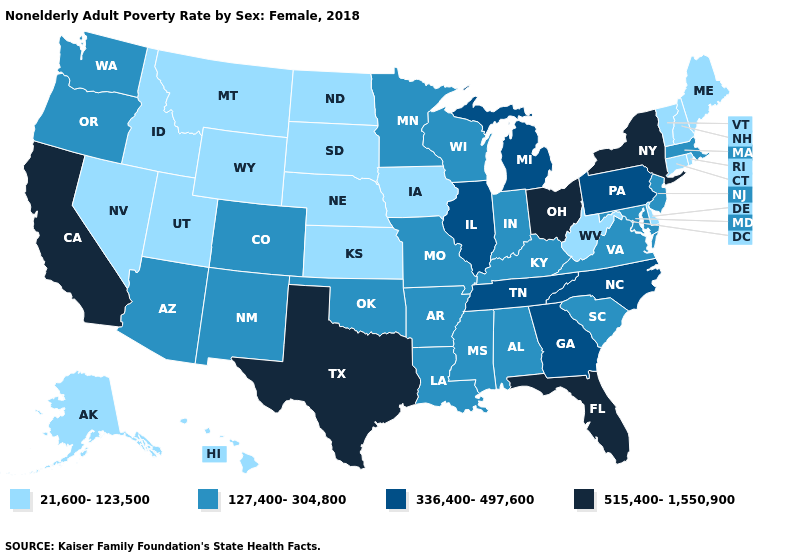What is the value of Mississippi?
Answer briefly. 127,400-304,800. What is the value of Massachusetts?
Concise answer only. 127,400-304,800. What is the value of Maryland?
Concise answer only. 127,400-304,800. How many symbols are there in the legend?
Concise answer only. 4. Does West Virginia have the lowest value in the South?
Be succinct. Yes. Name the states that have a value in the range 515,400-1,550,900?
Write a very short answer. California, Florida, New York, Ohio, Texas. Among the states that border North Carolina , which have the highest value?
Give a very brief answer. Georgia, Tennessee. Which states hav the highest value in the MidWest?
Keep it brief. Ohio. Does Tennessee have the highest value in the South?
Give a very brief answer. No. Name the states that have a value in the range 515,400-1,550,900?
Quick response, please. California, Florida, New York, Ohio, Texas. Is the legend a continuous bar?
Answer briefly. No. Which states have the lowest value in the USA?
Concise answer only. Alaska, Connecticut, Delaware, Hawaii, Idaho, Iowa, Kansas, Maine, Montana, Nebraska, Nevada, New Hampshire, North Dakota, Rhode Island, South Dakota, Utah, Vermont, West Virginia, Wyoming. Which states have the lowest value in the USA?
Answer briefly. Alaska, Connecticut, Delaware, Hawaii, Idaho, Iowa, Kansas, Maine, Montana, Nebraska, Nevada, New Hampshire, North Dakota, Rhode Island, South Dakota, Utah, Vermont, West Virginia, Wyoming. What is the value of Maine?
Answer briefly. 21,600-123,500. 